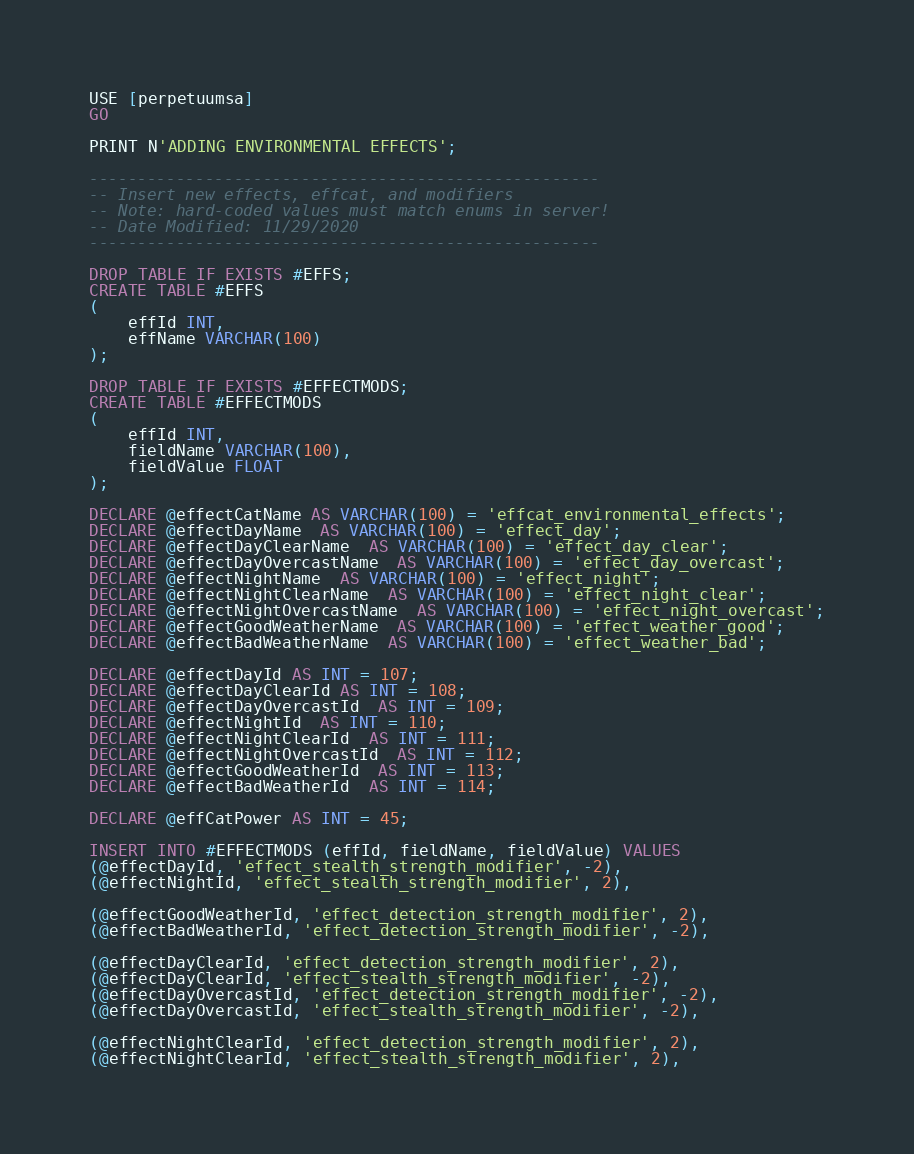<code> <loc_0><loc_0><loc_500><loc_500><_SQL_>USE [perpetuumsa]
GO

PRINT N'ADDING ENVIRONMENTAL EFFECTS';

-----------------------------------------------------
-- Insert new effects, effcat, and modifiers
-- Note: hard-coded values must match enums in server!
-- Date Modified: 11/29/2020
-----------------------------------------------------

DROP TABLE IF EXISTS #EFFS;
CREATE TABLE #EFFS 
(
	effId INT,
	effName VARCHAR(100)
);

DROP TABLE IF EXISTS #EFFECTMODS;
CREATE TABLE #EFFECTMODS 
(
	effId INT,
	fieldName VARCHAR(100),
	fieldValue FLOAT
);

DECLARE @effectCatName AS VARCHAR(100) = 'effcat_environmental_effects';
DECLARE @effectDayName  AS VARCHAR(100) = 'effect_day';
DECLARE @effectDayClearName  AS VARCHAR(100) = 'effect_day_clear';
DECLARE @effectDayOvercastName  AS VARCHAR(100) = 'effect_day_overcast';
DECLARE @effectNightName  AS VARCHAR(100) = 'effect_night';
DECLARE @effectNightClearName  AS VARCHAR(100) = 'effect_night_clear';
DECLARE @effectNightOvercastName  AS VARCHAR(100) = 'effect_night_overcast';
DECLARE @effectGoodWeatherName  AS VARCHAR(100) = 'effect_weather_good';
DECLARE @effectBadWeatherName  AS VARCHAR(100) = 'effect_weather_bad';

DECLARE @effectDayId AS INT = 107;
DECLARE @effectDayClearId AS INT = 108;
DECLARE @effectDayOvercastId  AS INT = 109;
DECLARE @effectNightId  AS INT = 110;
DECLARE @effectNightClearId  AS INT = 111;
DECLARE @effectNightOvercastId  AS INT = 112;
DECLARE @effectGoodWeatherId  AS INT = 113;
DECLARE @effectBadWeatherId  AS INT = 114;

DECLARE @effCatPower AS INT = 45;

INSERT INTO #EFFECTMODS (effId, fieldName, fieldValue) VALUES
(@effectDayId, 'effect_stealth_strength_modifier', -2),
(@effectNightId, 'effect_stealth_strength_modifier', 2),

(@effectGoodWeatherId, 'effect_detection_strength_modifier', 2),
(@effectBadWeatherId, 'effect_detection_strength_modifier', -2),

(@effectDayClearId, 'effect_detection_strength_modifier', 2),
(@effectDayClearId, 'effect_stealth_strength_modifier', -2),
(@effectDayOvercastId, 'effect_detection_strength_modifier', -2),
(@effectDayOvercastId, 'effect_stealth_strength_modifier', -2),

(@effectNightClearId, 'effect_detection_strength_modifier', 2),
(@effectNightClearId, 'effect_stealth_strength_modifier', 2),</code> 